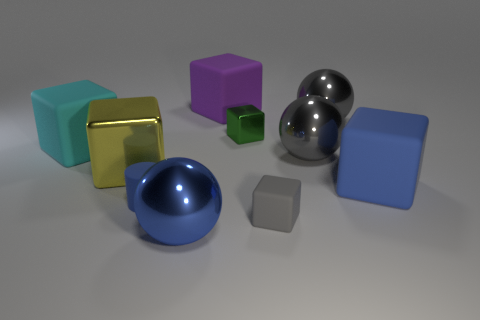Is the color of the sphere that is in front of the yellow shiny cube the same as the matte cylinder?
Offer a terse response. Yes. Are there any other things that are made of the same material as the big purple thing?
Give a very brief answer. Yes. What number of small green objects have the same shape as the gray matte thing?
Provide a short and direct response. 1. There is a green block that is made of the same material as the yellow object; what is its size?
Make the answer very short. Small. There is a small cube in front of the rubber object on the left side of the small blue cylinder; are there any spheres on the right side of it?
Keep it short and to the point. Yes. There is a rubber object that is behind the green block; is its size the same as the green metal block?
Provide a short and direct response. No. How many blue cylinders are the same size as the purple object?
Keep it short and to the point. 0. What is the shape of the green thing?
Keep it short and to the point. Cube. Are there any balls of the same color as the cylinder?
Offer a very short reply. Yes. Are there more rubber cubes behind the big cyan rubber block than large yellow cylinders?
Your answer should be compact. Yes. 